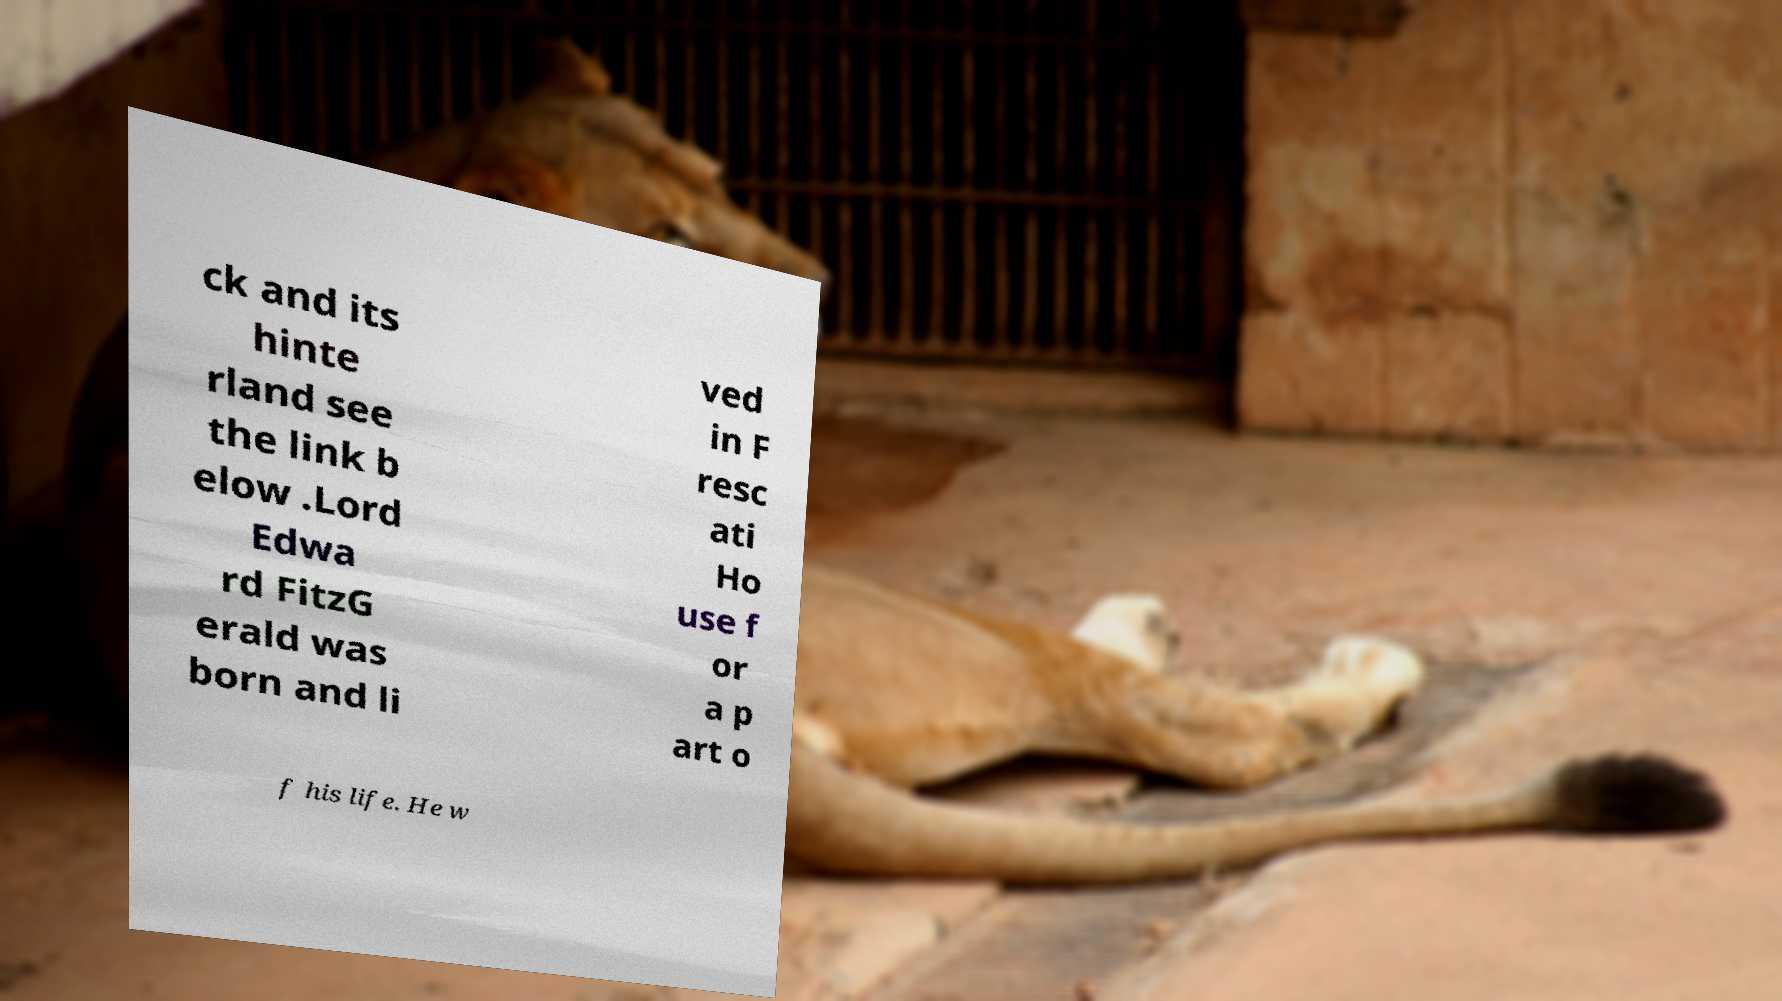Could you assist in decoding the text presented in this image and type it out clearly? ck and its hinte rland see the link b elow .Lord Edwa rd FitzG erald was born and li ved in F resc ati Ho use f or a p art o f his life. He w 